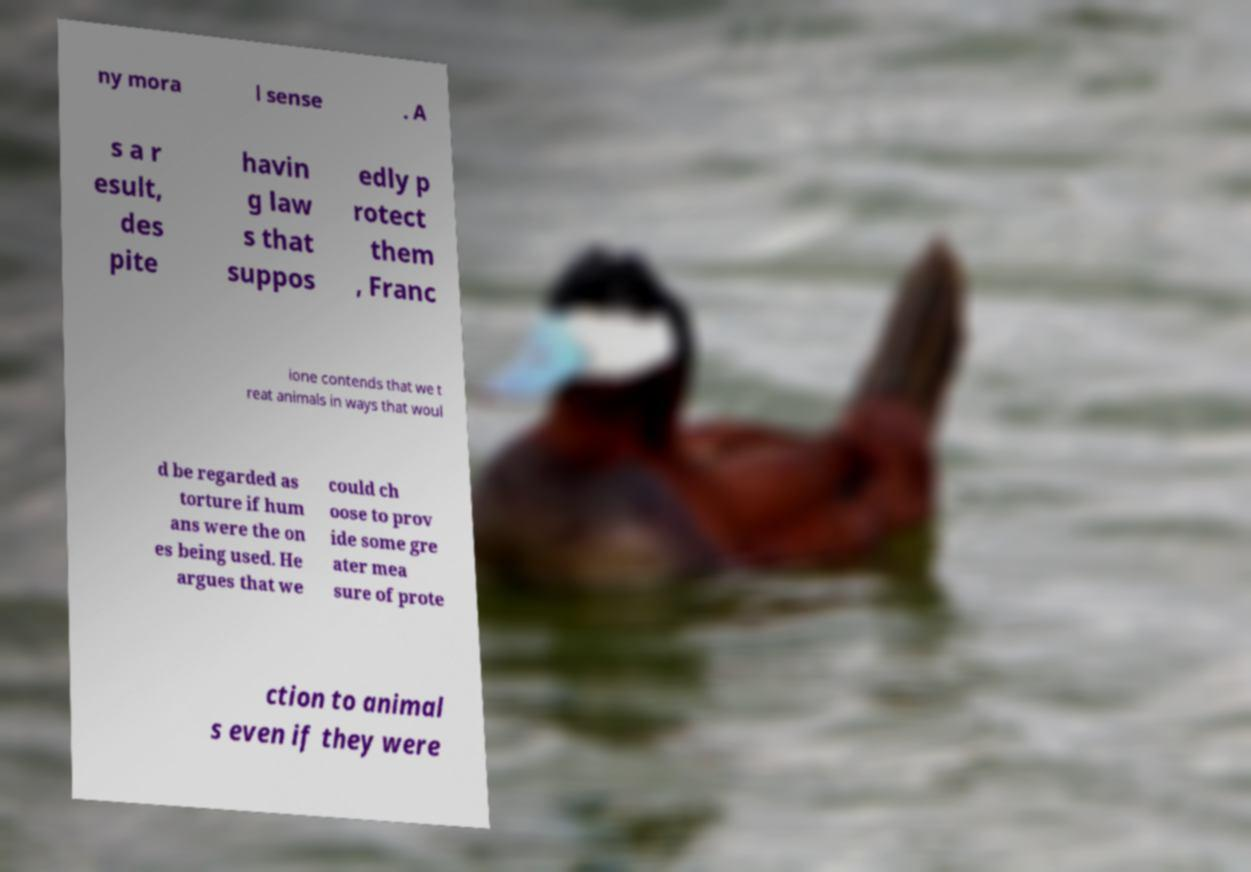Could you extract and type out the text from this image? ny mora l sense . A s a r esult, des pite havin g law s that suppos edly p rotect them , Franc ione contends that we t reat animals in ways that woul d be regarded as torture if hum ans were the on es being used. He argues that we could ch oose to prov ide some gre ater mea sure of prote ction to animal s even if they were 